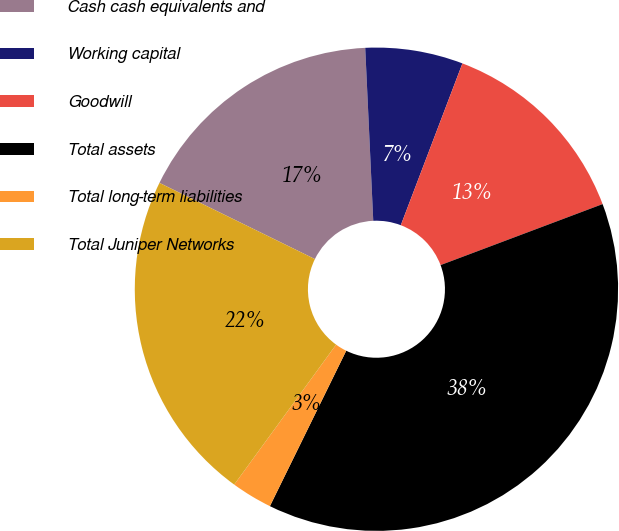Convert chart to OTSL. <chart><loc_0><loc_0><loc_500><loc_500><pie_chart><fcel>Cash cash equivalents and<fcel>Working capital<fcel>Goodwill<fcel>Total assets<fcel>Total long-term liabilities<fcel>Total Juniper Networks<nl><fcel>17.01%<fcel>6.53%<fcel>13.48%<fcel>38.0%<fcel>2.75%<fcel>22.24%<nl></chart> 